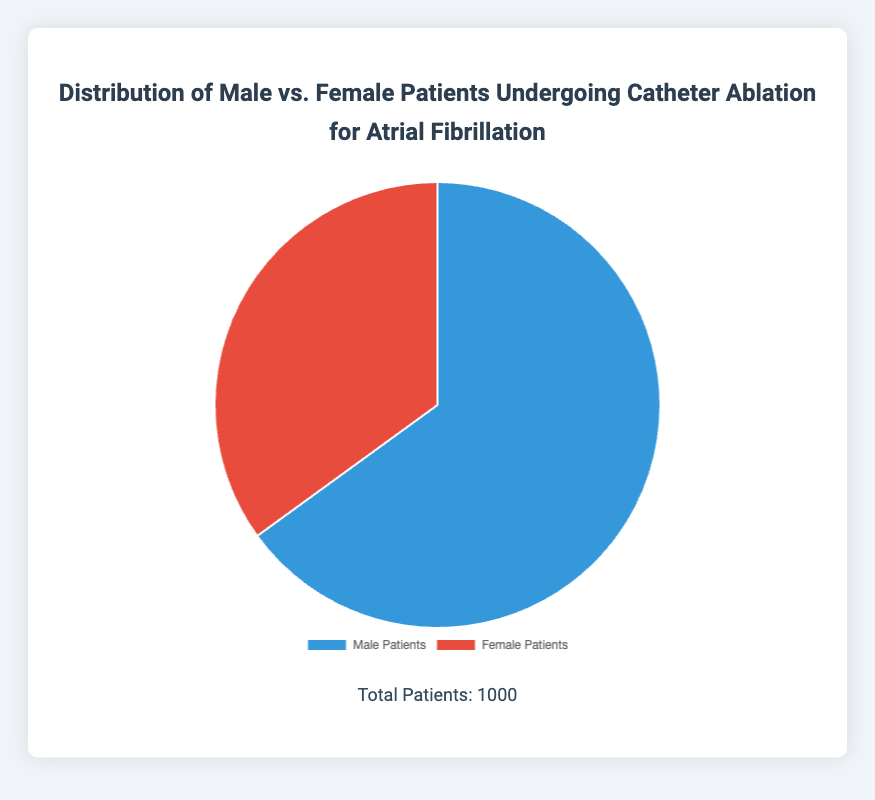What is the percentage of male patients undergoing catheter ablation for atrial fibrillation? The pie chart segments indicate that 65% of the patients are male.
Answer: 65% What is the total number of female patients undergoing catheter ablation for atrial fibrillation? The pie chart shows that 35% of the patients are female, and the total number of patients is 1000. Thus, the number of female patients is 35% of 1000, which is 350.
Answer: 350 How does the number of male patients compare to the number of female patients undergoing catheter ablation for atrial fibrillation? The number of male patients is 650, and the number of female patients is 350. 650 is greater than 350.
Answer: Male patients > Female patients What is the ratio of male to female patients undergoing catheter ablation for atrial fibrillation? The number of male patients is 650 and the number of female patients is 350. The ratio is 650:350, which simplifies to 13:7.
Answer: 13:7 What percentage of the total patients are represented by the difference between the number of male and female patients? The difference between the number of male (650) and female (350) patients is 300. To find the percentage, (300 / 1000) * 100 = 30%.
Answer: 30% What is the combined percentage of male and female patients undergoing catheter ablation for atrial fibrillation? The sum of the percentages of male and female patients is 65% + 35%, which equals 100%.
Answer: 100% Which color represents the female patients in the distribution pie chart? The pie chart uses red to represent female patients.
Answer: Red 